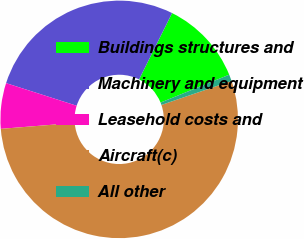<chart> <loc_0><loc_0><loc_500><loc_500><pie_chart><fcel>Buildings structures and<fcel>Machinery and equipment<fcel>Leasehold costs and<fcel>Aircraft(c)<fcel>All other<nl><fcel>11.51%<fcel>27.41%<fcel>6.21%<fcel>53.97%<fcel>0.9%<nl></chart> 